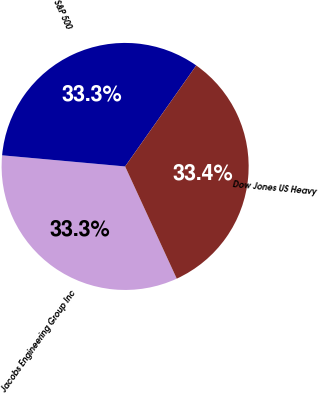Convert chart. <chart><loc_0><loc_0><loc_500><loc_500><pie_chart><fcel>Jacobs Engineering Group Inc<fcel>S&P 500<fcel>Dow Jones US Heavy<nl><fcel>33.3%<fcel>33.33%<fcel>33.37%<nl></chart> 